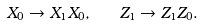Convert formula to latex. <formula><loc_0><loc_0><loc_500><loc_500>X _ { 0 } \to X _ { 1 } X _ { 0 } , \quad Z _ { 1 } \to Z _ { 1 } Z _ { 0 } .</formula> 